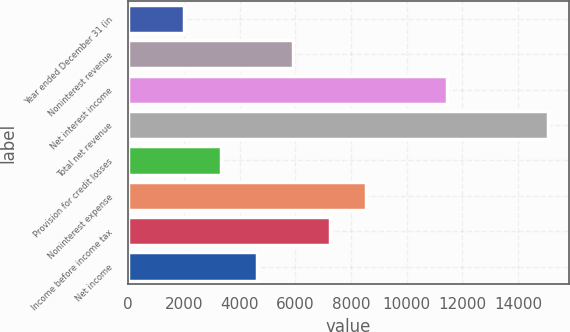Convert chart. <chart><loc_0><loc_0><loc_500><loc_500><bar_chart><fcel>Year ended December 31 (in<fcel>Noninterest revenue<fcel>Net interest income<fcel>Total net revenue<fcel>Provision for credit losses<fcel>Noninterest expense<fcel>Income before income tax<fcel>Net income<nl><fcel>2014<fcel>5926.3<fcel>11462<fcel>15055<fcel>3318.1<fcel>8534.5<fcel>7230.4<fcel>4622.2<nl></chart> 